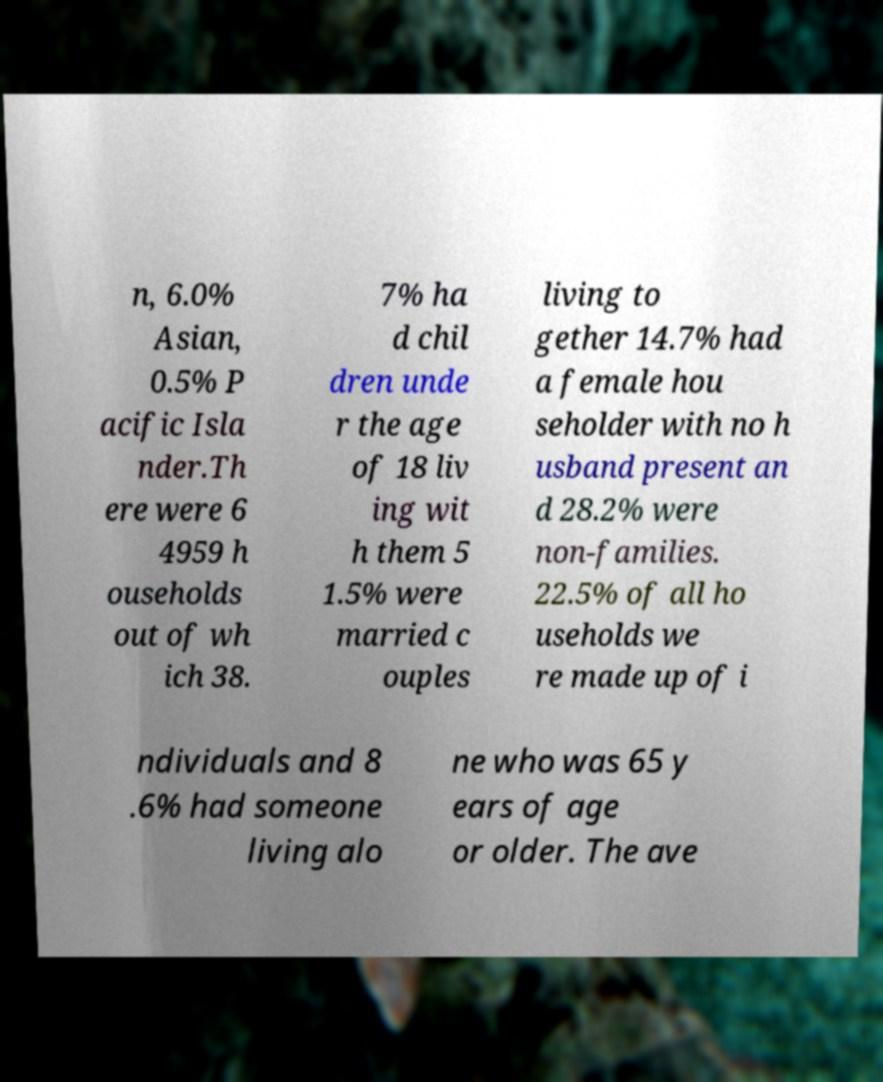Can you read and provide the text displayed in the image?This photo seems to have some interesting text. Can you extract and type it out for me? n, 6.0% Asian, 0.5% P acific Isla nder.Th ere were 6 4959 h ouseholds out of wh ich 38. 7% ha d chil dren unde r the age of 18 liv ing wit h them 5 1.5% were married c ouples living to gether 14.7% had a female hou seholder with no h usband present an d 28.2% were non-families. 22.5% of all ho useholds we re made up of i ndividuals and 8 .6% had someone living alo ne who was 65 y ears of age or older. The ave 